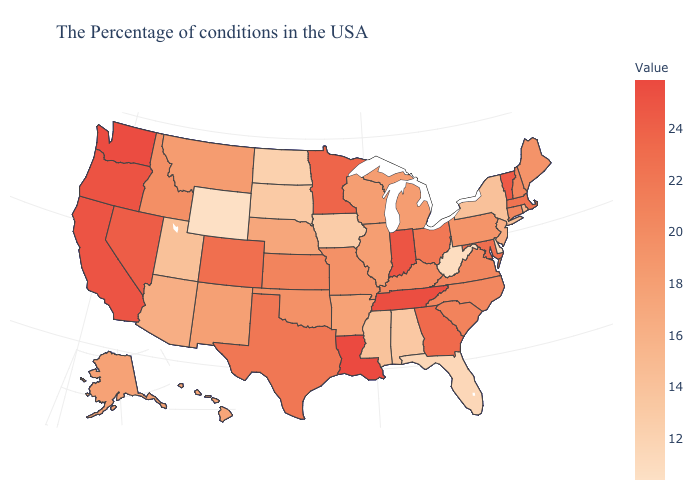Is the legend a continuous bar?
Write a very short answer. Yes. Which states have the highest value in the USA?
Be succinct. Louisiana. Does Michigan have a lower value than California?
Write a very short answer. Yes. Does Louisiana have the highest value in the USA?
Be succinct. Yes. Which states hav the highest value in the West?
Concise answer only. Washington. Among the states that border California , which have the highest value?
Be succinct. Oregon. 